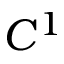<formula> <loc_0><loc_0><loc_500><loc_500>C ^ { 1 }</formula> 